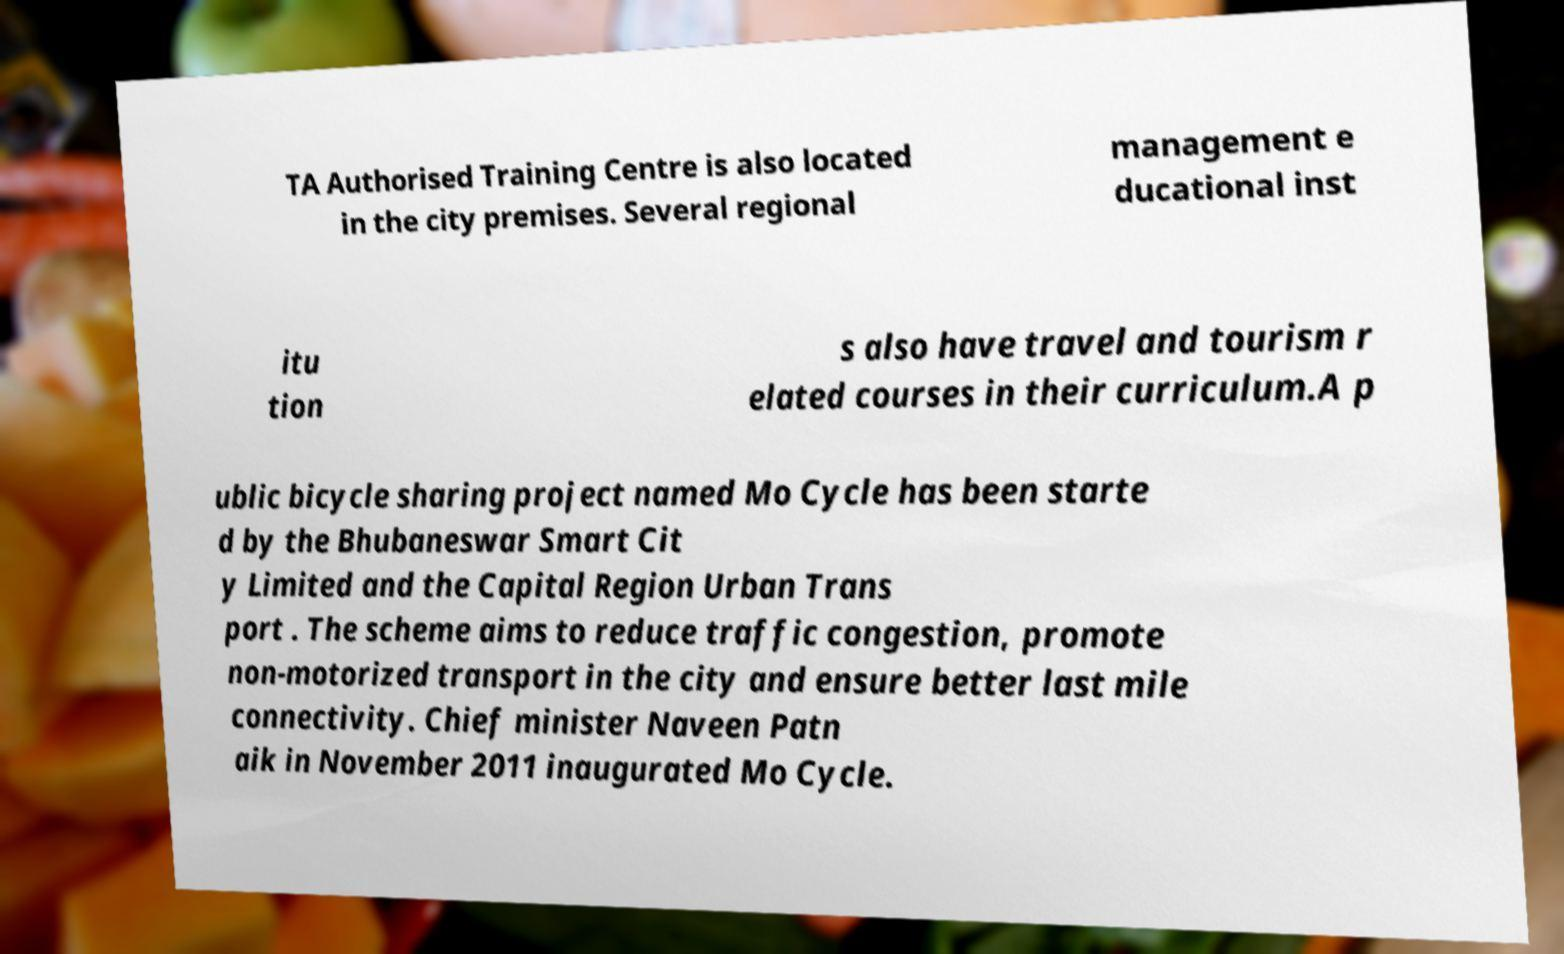Could you assist in decoding the text presented in this image and type it out clearly? TA Authorised Training Centre is also located in the city premises. Several regional management e ducational inst itu tion s also have travel and tourism r elated courses in their curriculum.A p ublic bicycle sharing project named Mo Cycle has been starte d by the Bhubaneswar Smart Cit y Limited and the Capital Region Urban Trans port . The scheme aims to reduce traffic congestion, promote non-motorized transport in the city and ensure better last mile connectivity. Chief minister Naveen Patn aik in November 2011 inaugurated Mo Cycle. 